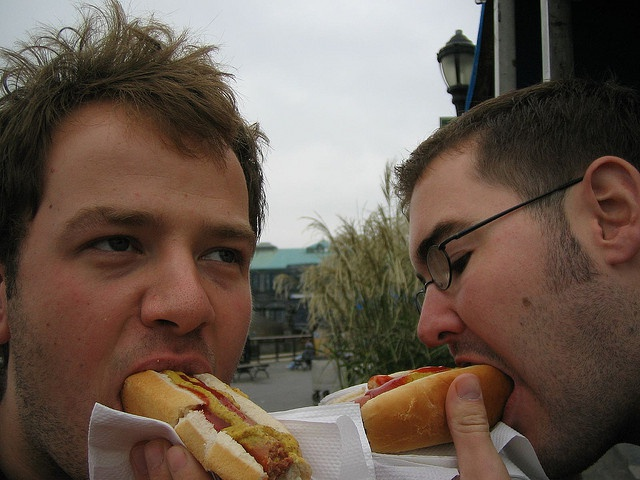Describe the objects in this image and their specific colors. I can see people in darkgray, maroon, black, brown, and gray tones, people in darkgray, black, maroon, and brown tones, hot dog in darkgray, olive, tan, and maroon tones, hot dog in darkgray, maroon, brown, and black tones, and bench in darkgray, black, and gray tones in this image. 